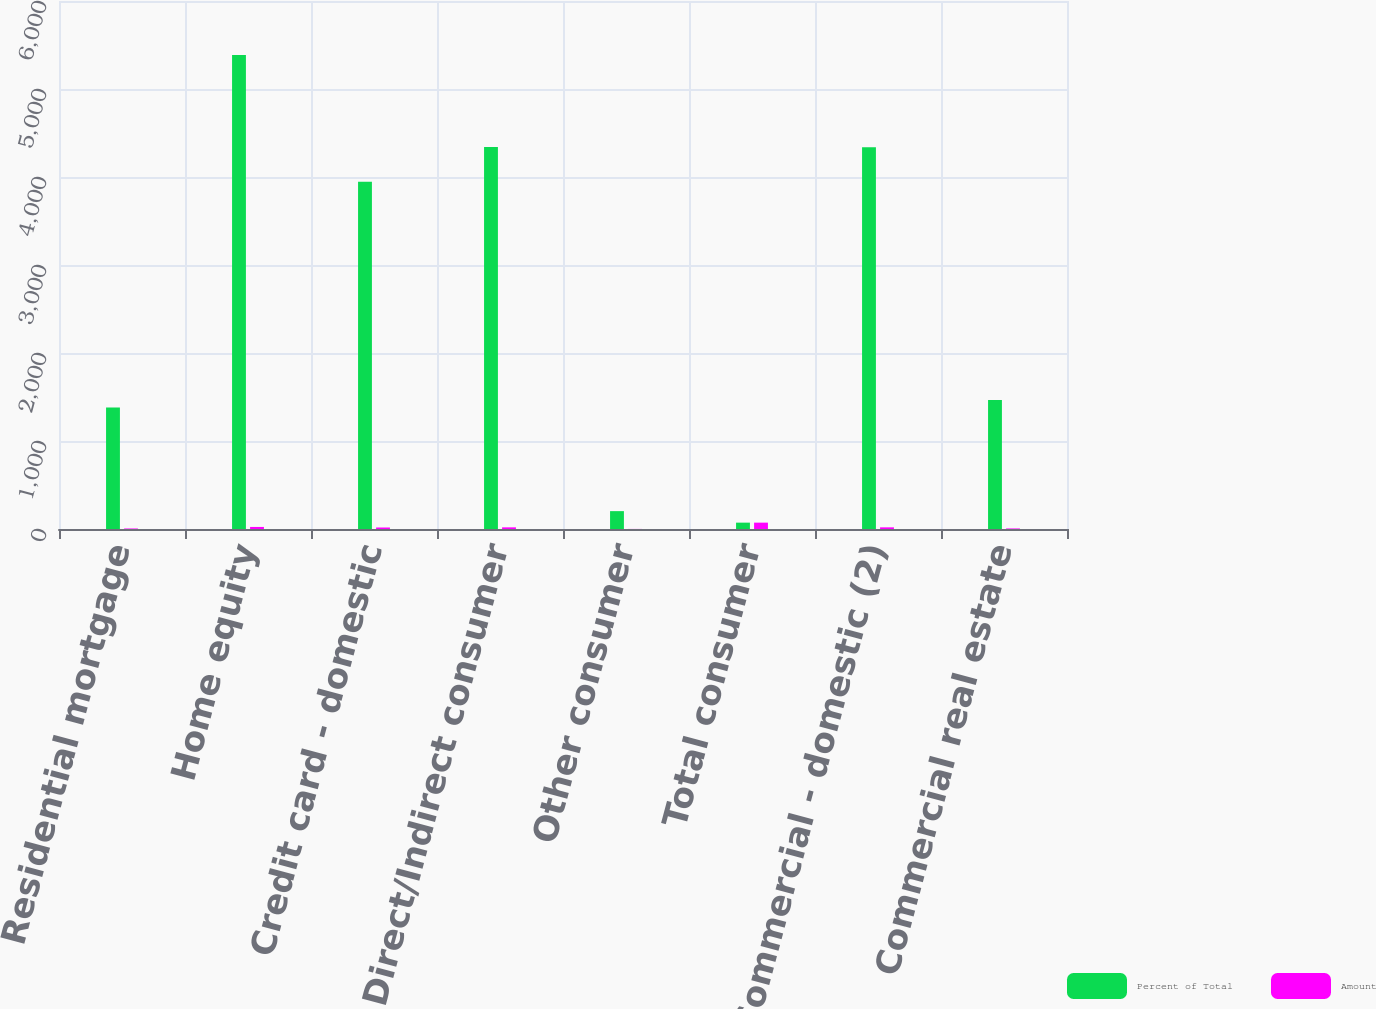<chart> <loc_0><loc_0><loc_500><loc_500><stacked_bar_chart><ecel><fcel>Residential mortgage<fcel>Home equity<fcel>Credit card - domestic<fcel>Direct/Indirect consumer<fcel>Other consumer<fcel>Total consumer<fcel>Commercial - domestic (2)<fcel>Commercial real estate<nl><fcel>Percent of Total<fcel>1382<fcel>5385<fcel>3947<fcel>4341<fcel>203<fcel>72.2<fcel>4339<fcel>1465<nl><fcel>Amount<fcel>5.99<fcel>23.34<fcel>17.11<fcel>18.81<fcel>0.88<fcel>72.2<fcel>18.81<fcel>6.35<nl></chart> 